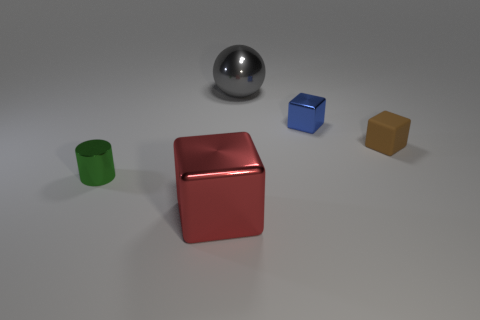Are there any other things that are the same shape as the big gray object?
Make the answer very short. No. Is there a small brown thing that has the same shape as the blue object?
Ensure brevity in your answer.  Yes. How many other objects are there of the same color as the tiny metallic cylinder?
Your answer should be compact. 0. Are there fewer brown rubber blocks that are in front of the small brown matte thing than cyan cylinders?
Give a very brief answer. No. How many red shiny things are there?
Offer a terse response. 1. How many large objects have the same material as the tiny green object?
Offer a terse response. 2. How many objects are small metal objects that are on the right side of the big red metallic block or tiny red matte things?
Offer a very short reply. 1. Is the number of big things in front of the blue thing less than the number of things that are to the left of the tiny brown block?
Offer a terse response. Yes. There is a blue metallic thing; are there any big things behind it?
Provide a short and direct response. Yes. How many objects are either objects that are on the right side of the gray metallic sphere or blocks that are left of the small brown cube?
Your response must be concise. 3. 